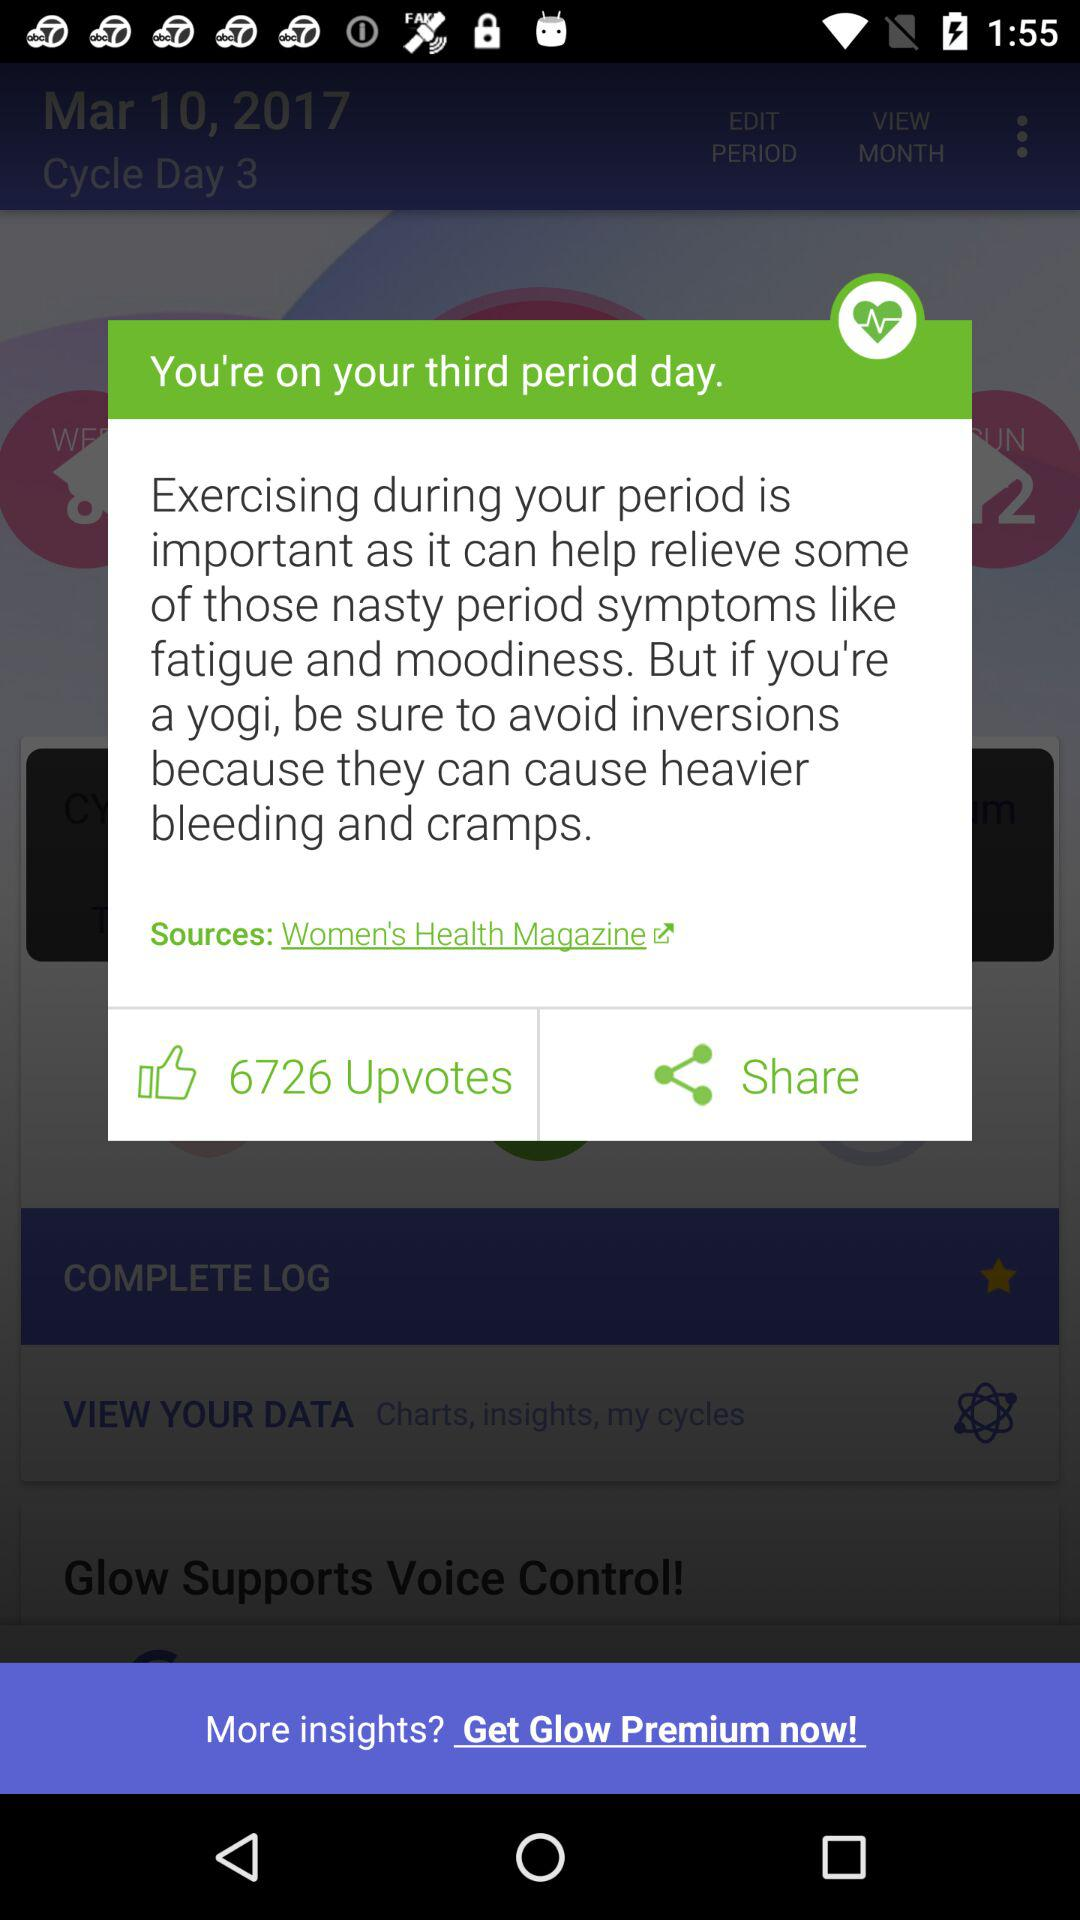How many upvotes were received? The number of received upvotes is 6726. 